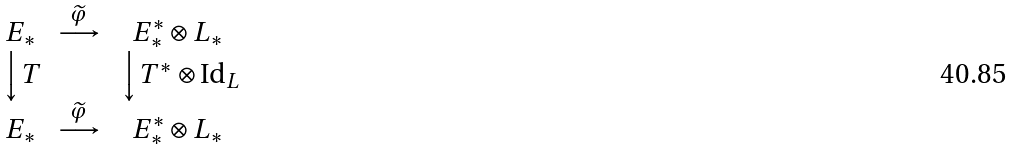Convert formula to latex. <formula><loc_0><loc_0><loc_500><loc_500>\begin{matrix} E _ { * } & \stackrel { \widetilde { \varphi } } { \longrightarrow } & E ^ { * } _ { * } \otimes L _ { * } \\ \Big \downarrow T & & \, \Big \downarrow T ^ { * } \otimes \text {Id} _ { L } \\ E _ { * } & \stackrel { \widetilde { \varphi } } { \longrightarrow } & E ^ { * } _ { * } \otimes L _ { * } \end{matrix}</formula> 